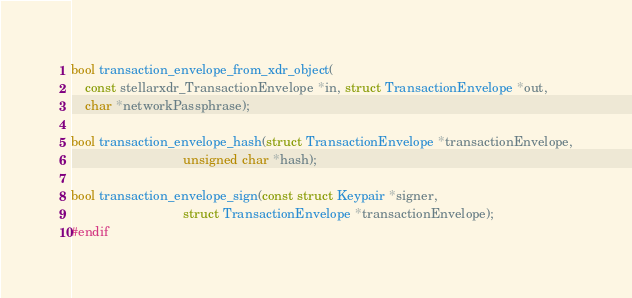Convert code to text. <code><loc_0><loc_0><loc_500><loc_500><_C_>
bool transaction_envelope_from_xdr_object(
    const stellarxdr_TransactionEnvelope *in, struct TransactionEnvelope *out,
    char *networkPassphrase);

bool transaction_envelope_hash(struct TransactionEnvelope *transactionEnvelope,
                               unsigned char *hash);

bool transaction_envelope_sign(const struct Keypair *signer,
                               struct TransactionEnvelope *transactionEnvelope);
#endif
</code> 